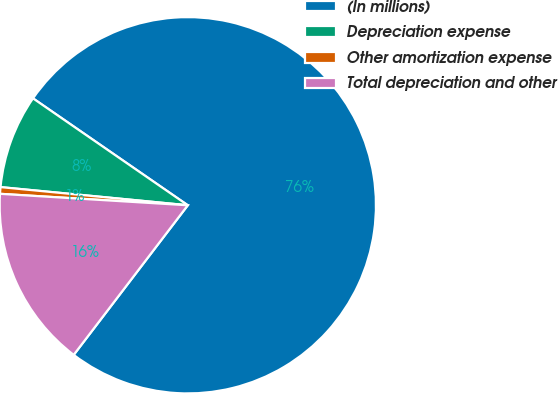Convert chart to OTSL. <chart><loc_0><loc_0><loc_500><loc_500><pie_chart><fcel>(In millions)<fcel>Depreciation expense<fcel>Other amortization expense<fcel>Total depreciation and other<nl><fcel>75.75%<fcel>8.08%<fcel>0.57%<fcel>15.6%<nl></chart> 